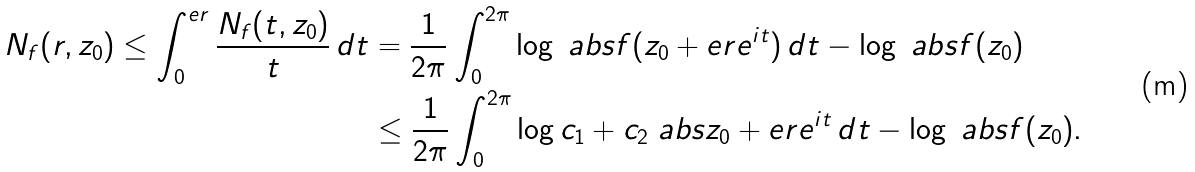<formula> <loc_0><loc_0><loc_500><loc_500>N _ { f } ( r , z _ { 0 } ) \leq \int _ { 0 } ^ { e r } \frac { N _ { f } ( t , z _ { 0 } ) } { t } \, d t & = \frac { 1 } { 2 \pi } \int _ { 0 } ^ { 2 \pi } \log \ a b s { f ( z _ { 0 } + e r e ^ { i t } ) } \, d t - \log \ a b s { f ( z _ { 0 } ) } \\ & \leq \frac { 1 } { 2 \pi } \int _ { 0 } ^ { 2 \pi } \log c _ { 1 } + c _ { 2 } \ a b s { z _ { 0 } + e r e ^ { i t } } \, d t - \log \ a b s { f ( z _ { 0 } ) } .</formula> 